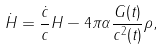Convert formula to latex. <formula><loc_0><loc_0><loc_500><loc_500>\dot { H } = \frac { \dot { c } } { c } H - 4 \pi \alpha \frac { G ( t ) } { c ^ { 2 } ( t ) } \rho ,</formula> 